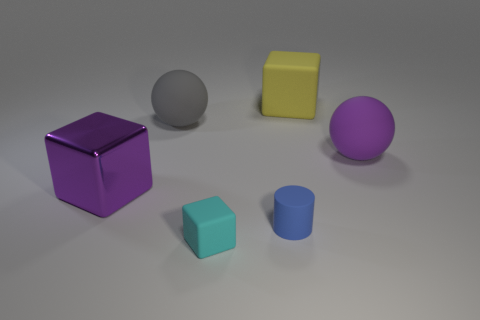What emotions does the color palette in the image evoke? The color palette in the image evokes a sense of modernity and playfulness. The use of primary colors like yellow and blue, mixed with secondary colors like purple, creates a vibrant yet balanced visual experience. It's reminiscent of contemporary design and might inspire creativity or curiosity in viewers. 